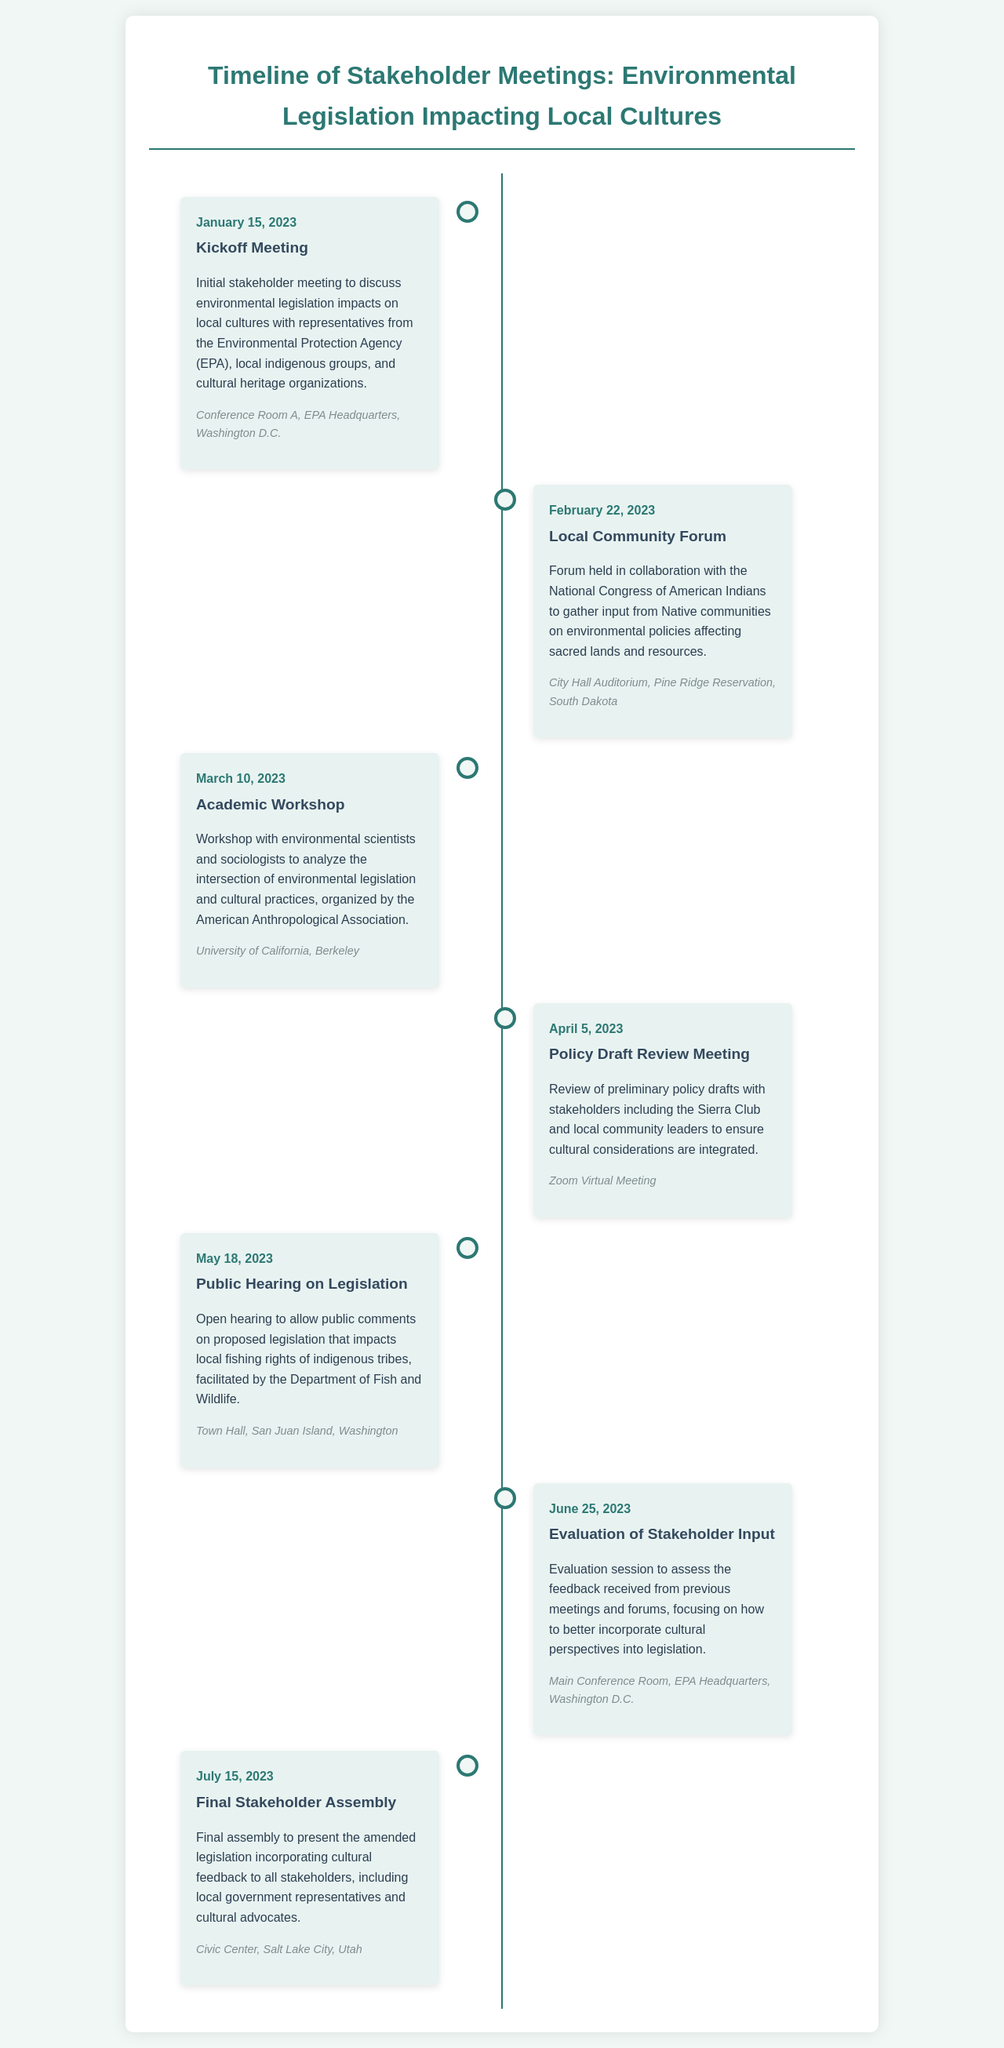What is the date of the Kickoff Meeting? The date is specified in the document as January 15, 2023.
Answer: January 15, 2023 Who organized the Academic Workshop? The document states that the American Anthropological Association organized the workshop.
Answer: American Anthropological Association Where was the Public Hearing on Legislation held? The location of the hearing is mentioned as Town Hall, San Juan Island, Washington.
Answer: Town Hall, San Juan Island, Washington Which meeting focused on sacred lands and resources? The Local Community Forum specifically addressed input from Native communities on environmental policies affecting sacred lands.
Answer: Local Community Forum What was the purpose of the Evaluation of Stakeholder Input? The document indicates that it was to assess feedback received and incorporate cultural perspectives into legislation.
Answer: Assess feedback and incorporate cultural perspectives How many stakeholder meetings are listed in the timeline? The number of events listed in the timeline can be counted from the document. There are six events.
Answer: Six What type of meeting was held on April 5, 2023? The document categorizes it as a Policy Draft Review Meeting.
Answer: Policy Draft Review Meeting When was the Final Stakeholder Assembly scheduled? The date of the assembly is specified as July 15, 2023 in the document.
Answer: July 15, 2023 What type of meeting was the February 22, 2023 event? It is classified as a Local Community Forum in the timeline.
Answer: Local Community Forum 